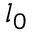Convert formula to latex. <formula><loc_0><loc_0><loc_500><loc_500>l _ { 0 }</formula> 